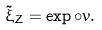<formula> <loc_0><loc_0><loc_500><loc_500>\tilde { \xi } _ { Z } = \exp \circ v .</formula> 